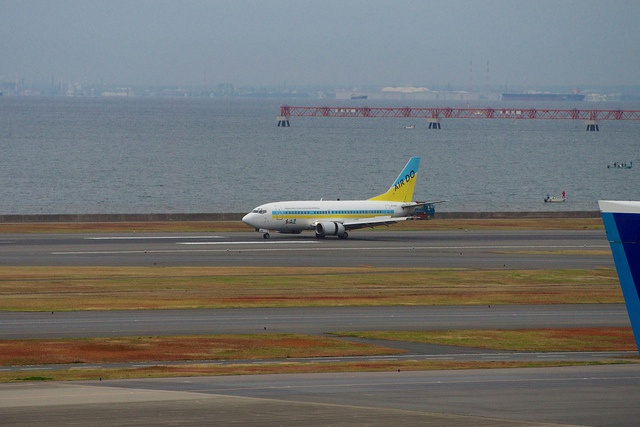Describe the objects in this image and their specific colors. I can see airplane in darkgray, lightgray, gray, and olive tones, boat in darkgray and gray tones, boat in darkgray, gray, blue, and navy tones, boat in darkgray, gray, and black tones, and boat in gray and darkgray tones in this image. 